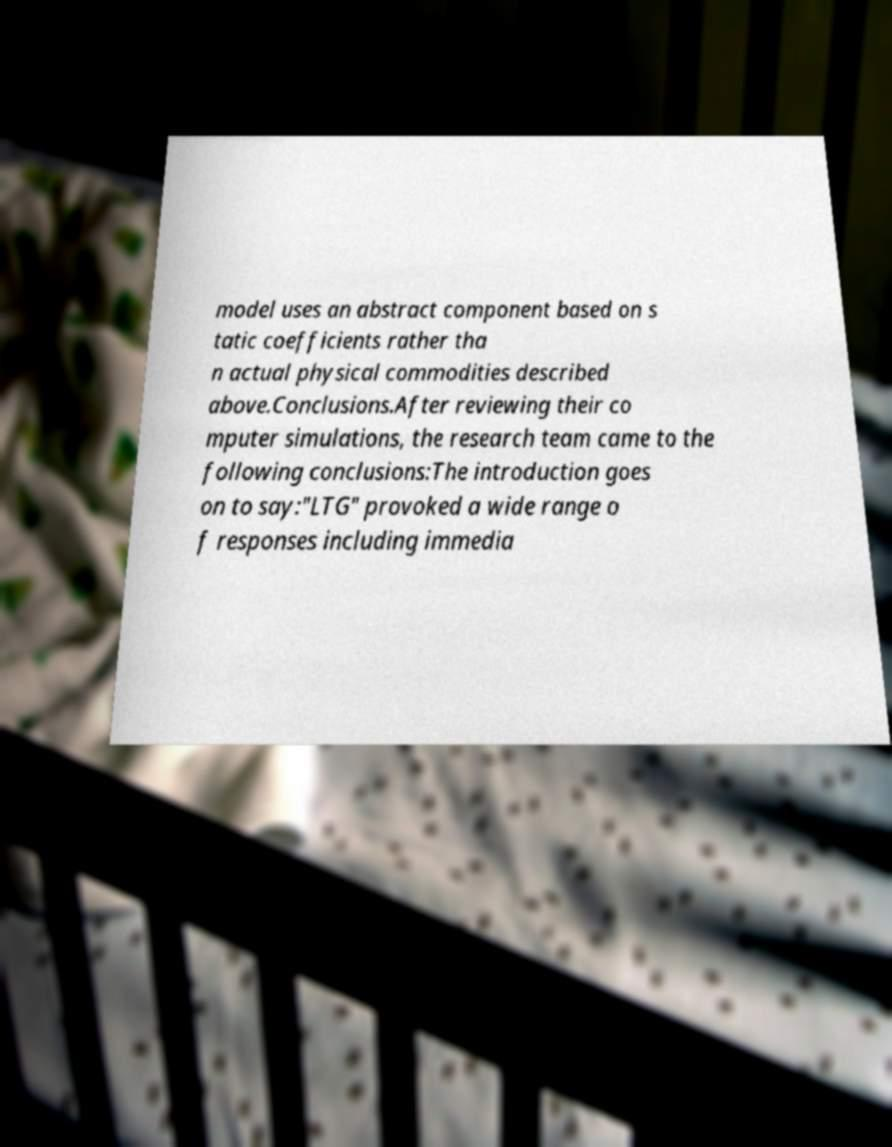There's text embedded in this image that I need extracted. Can you transcribe it verbatim? model uses an abstract component based on s tatic coefficients rather tha n actual physical commodities described above.Conclusions.After reviewing their co mputer simulations, the research team came to the following conclusions:The introduction goes on to say:"LTG" provoked a wide range o f responses including immedia 